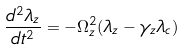Convert formula to latex. <formula><loc_0><loc_0><loc_500><loc_500>\frac { d ^ { 2 } \lambda _ { z } } { d t ^ { 2 } } = - \Omega _ { z } ^ { 2 } ( \lambda _ { z } - \gamma _ { z } \lambda _ { c } )</formula> 